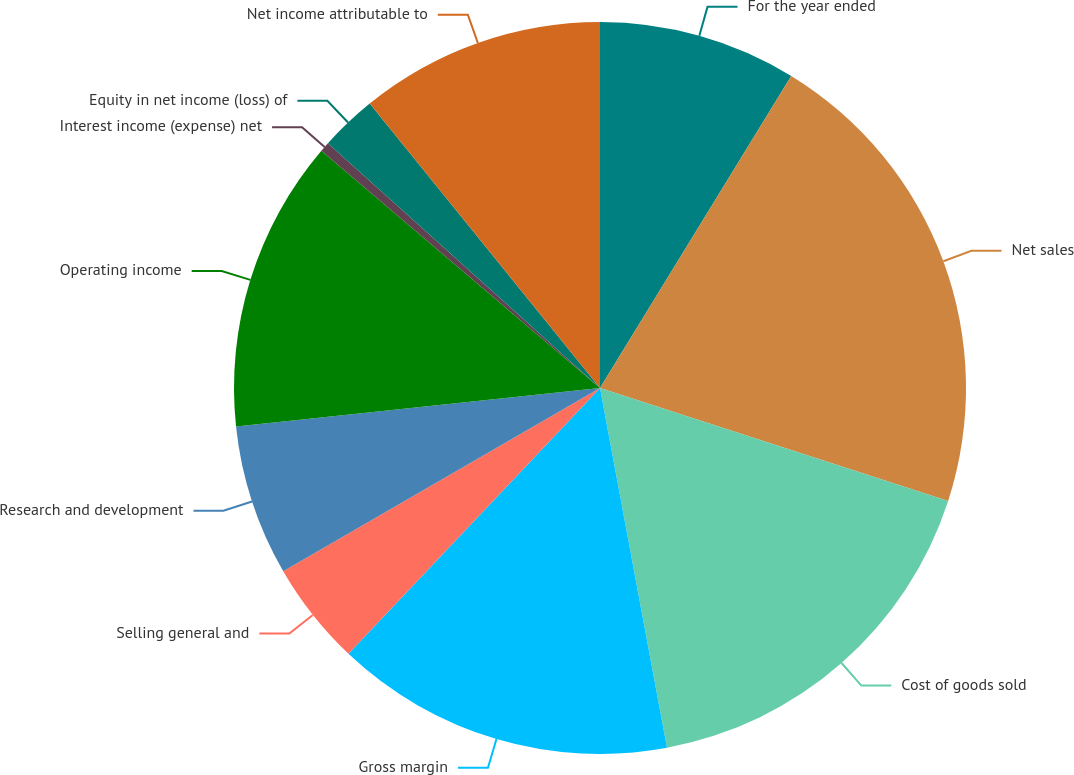Convert chart. <chart><loc_0><loc_0><loc_500><loc_500><pie_chart><fcel>For the year ended<fcel>Net sales<fcel>Cost of goods sold<fcel>Gross margin<fcel>Selling general and<fcel>Research and development<fcel>Operating income<fcel>Interest income (expense) net<fcel>Equity in net income (loss) of<fcel>Net income attributable to<nl><fcel>8.75%<fcel>21.24%<fcel>17.08%<fcel>14.99%<fcel>4.59%<fcel>6.67%<fcel>12.91%<fcel>0.43%<fcel>2.51%<fcel>10.83%<nl></chart> 